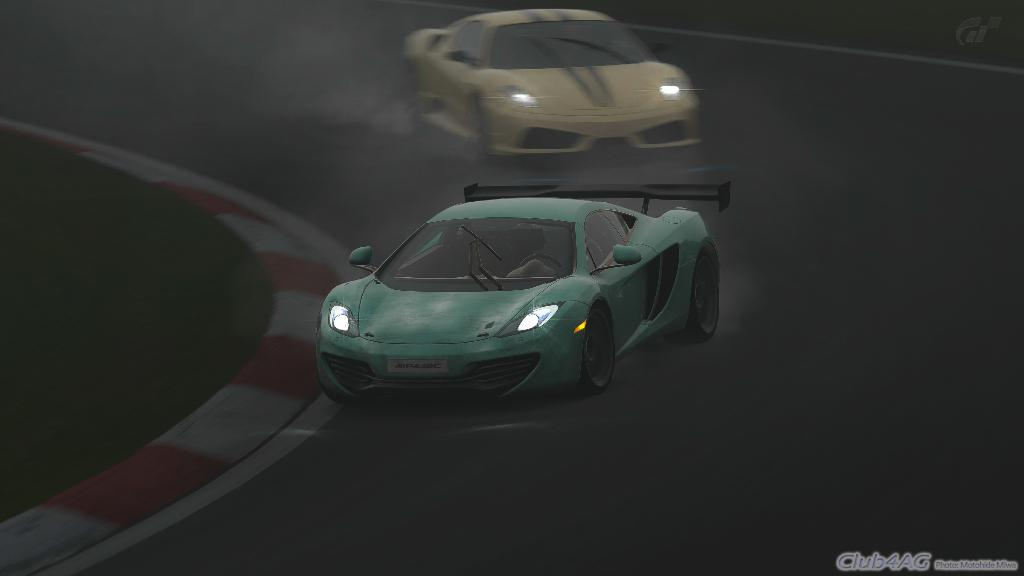How many cars are on the road in the image? There are two cars on the road in the image. What type of vegetation can be seen in the image? There is grass visible in the image. What type of linen is draped over the seat of the goose in the image? There is no goose or seat with linen present in the image. 